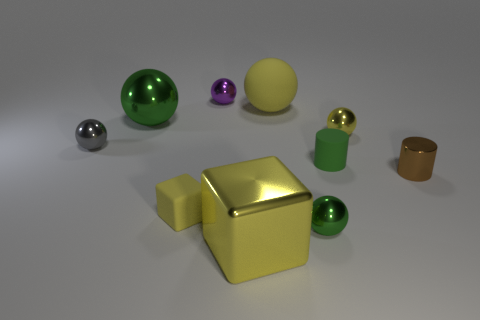Subtract all large rubber spheres. How many spheres are left? 5 Subtract 5 spheres. How many spheres are left? 1 Subtract all gray spheres. How many spheres are left? 5 Subtract all cylinders. How many objects are left? 8 Add 4 green spheres. How many green spheres are left? 6 Add 3 tiny gray rubber things. How many tiny gray rubber things exist? 3 Subtract 1 brown cylinders. How many objects are left? 9 Subtract all brown blocks. Subtract all gray spheres. How many blocks are left? 2 Subtract all blue blocks. How many brown balls are left? 0 Subtract all yellow objects. Subtract all green matte objects. How many objects are left? 5 